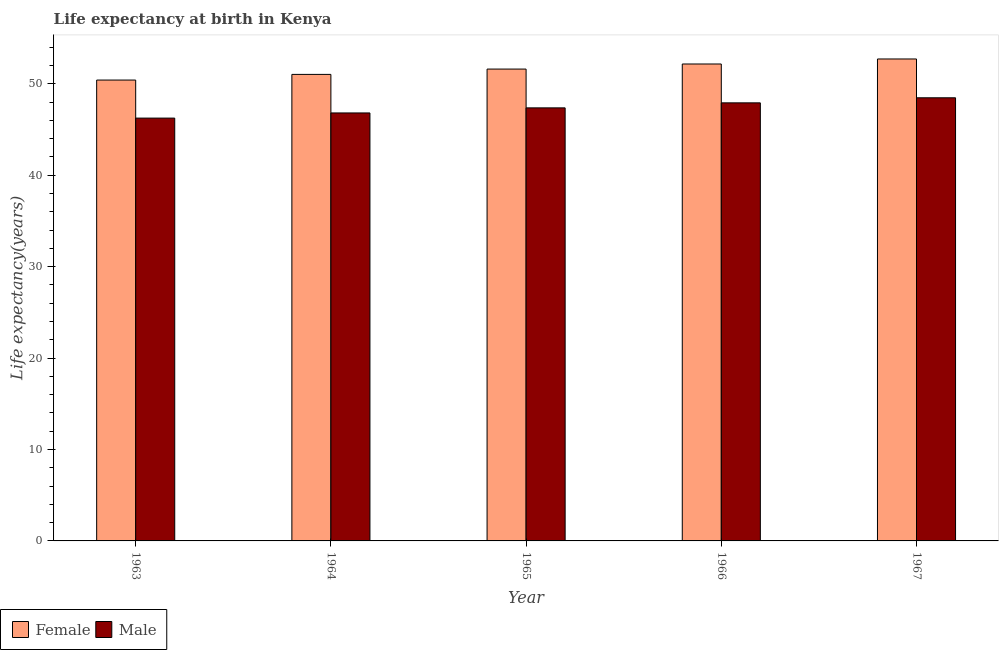How many different coloured bars are there?
Make the answer very short. 2. How many groups of bars are there?
Your response must be concise. 5. How many bars are there on the 4th tick from the left?
Ensure brevity in your answer.  2. What is the label of the 5th group of bars from the left?
Provide a succinct answer. 1967. What is the life expectancy(male) in 1963?
Your response must be concise. 46.24. Across all years, what is the maximum life expectancy(male)?
Offer a terse response. 48.46. Across all years, what is the minimum life expectancy(female)?
Make the answer very short. 50.4. In which year was the life expectancy(female) maximum?
Your response must be concise. 1967. What is the total life expectancy(female) in the graph?
Your response must be concise. 257.89. What is the difference between the life expectancy(male) in 1963 and that in 1966?
Make the answer very short. -1.67. What is the difference between the life expectancy(female) in 1963 and the life expectancy(male) in 1966?
Your answer should be compact. -1.76. What is the average life expectancy(female) per year?
Offer a terse response. 51.58. In how many years, is the life expectancy(male) greater than 22 years?
Provide a short and direct response. 5. What is the ratio of the life expectancy(female) in 1963 to that in 1967?
Ensure brevity in your answer.  0.96. Is the life expectancy(male) in 1963 less than that in 1964?
Make the answer very short. Yes. What is the difference between the highest and the second highest life expectancy(female)?
Keep it short and to the point. 0.55. What is the difference between the highest and the lowest life expectancy(male)?
Provide a succinct answer. 2.22. In how many years, is the life expectancy(female) greater than the average life expectancy(female) taken over all years?
Make the answer very short. 3. Is the sum of the life expectancy(female) in 1965 and 1967 greater than the maximum life expectancy(male) across all years?
Ensure brevity in your answer.  Yes. What does the 1st bar from the left in 1965 represents?
Provide a short and direct response. Female. How many years are there in the graph?
Your answer should be very brief. 5. Does the graph contain any zero values?
Keep it short and to the point. No. Does the graph contain grids?
Provide a succinct answer. No. How are the legend labels stacked?
Your answer should be compact. Horizontal. What is the title of the graph?
Your answer should be compact. Life expectancy at birth in Kenya. What is the label or title of the X-axis?
Ensure brevity in your answer.  Year. What is the label or title of the Y-axis?
Your answer should be very brief. Life expectancy(years). What is the Life expectancy(years) in Female in 1963?
Keep it short and to the point. 50.4. What is the Life expectancy(years) of Male in 1963?
Provide a succinct answer. 46.24. What is the Life expectancy(years) of Female in 1964?
Offer a very short reply. 51.02. What is the Life expectancy(years) of Male in 1964?
Ensure brevity in your answer.  46.8. What is the Life expectancy(years) in Female in 1965?
Keep it short and to the point. 51.6. What is the Life expectancy(years) of Male in 1965?
Ensure brevity in your answer.  47.36. What is the Life expectancy(years) in Female in 1966?
Offer a terse response. 52.16. What is the Life expectancy(years) of Male in 1966?
Make the answer very short. 47.91. What is the Life expectancy(years) of Female in 1967?
Your response must be concise. 52.71. What is the Life expectancy(years) of Male in 1967?
Your response must be concise. 48.46. Across all years, what is the maximum Life expectancy(years) of Female?
Your answer should be very brief. 52.71. Across all years, what is the maximum Life expectancy(years) of Male?
Keep it short and to the point. 48.46. Across all years, what is the minimum Life expectancy(years) of Female?
Keep it short and to the point. 50.4. Across all years, what is the minimum Life expectancy(years) of Male?
Ensure brevity in your answer.  46.24. What is the total Life expectancy(years) of Female in the graph?
Give a very brief answer. 257.89. What is the total Life expectancy(years) of Male in the graph?
Ensure brevity in your answer.  236.78. What is the difference between the Life expectancy(years) in Female in 1963 and that in 1964?
Provide a succinct answer. -0.62. What is the difference between the Life expectancy(years) in Male in 1963 and that in 1964?
Ensure brevity in your answer.  -0.56. What is the difference between the Life expectancy(years) of Female in 1963 and that in 1965?
Your answer should be very brief. -1.2. What is the difference between the Life expectancy(years) in Male in 1963 and that in 1965?
Your answer should be compact. -1.12. What is the difference between the Life expectancy(years) of Female in 1963 and that in 1966?
Make the answer very short. -1.76. What is the difference between the Life expectancy(years) of Male in 1963 and that in 1966?
Ensure brevity in your answer.  -1.67. What is the difference between the Life expectancy(years) in Female in 1963 and that in 1967?
Give a very brief answer. -2.31. What is the difference between the Life expectancy(years) in Male in 1963 and that in 1967?
Your answer should be compact. -2.22. What is the difference between the Life expectancy(years) of Female in 1964 and that in 1965?
Offer a terse response. -0.58. What is the difference between the Life expectancy(years) of Male in 1964 and that in 1965?
Keep it short and to the point. -0.55. What is the difference between the Life expectancy(years) in Female in 1964 and that in 1966?
Provide a succinct answer. -1.14. What is the difference between the Life expectancy(years) in Male in 1964 and that in 1966?
Ensure brevity in your answer.  -1.1. What is the difference between the Life expectancy(years) of Female in 1964 and that in 1967?
Your answer should be compact. -1.69. What is the difference between the Life expectancy(years) in Male in 1964 and that in 1967?
Offer a very short reply. -1.66. What is the difference between the Life expectancy(years) in Female in 1965 and that in 1966?
Ensure brevity in your answer.  -0.56. What is the difference between the Life expectancy(years) in Male in 1965 and that in 1966?
Provide a short and direct response. -0.55. What is the difference between the Life expectancy(years) of Female in 1965 and that in 1967?
Provide a succinct answer. -1.1. What is the difference between the Life expectancy(years) in Male in 1965 and that in 1967?
Your response must be concise. -1.1. What is the difference between the Life expectancy(years) of Female in 1966 and that in 1967?
Give a very brief answer. -0.55. What is the difference between the Life expectancy(years) in Male in 1966 and that in 1967?
Make the answer very short. -0.55. What is the difference between the Life expectancy(years) in Female in 1963 and the Life expectancy(years) in Male in 1964?
Offer a terse response. 3.6. What is the difference between the Life expectancy(years) of Female in 1963 and the Life expectancy(years) of Male in 1965?
Provide a short and direct response. 3.04. What is the difference between the Life expectancy(years) in Female in 1963 and the Life expectancy(years) in Male in 1966?
Your answer should be very brief. 2.49. What is the difference between the Life expectancy(years) of Female in 1963 and the Life expectancy(years) of Male in 1967?
Ensure brevity in your answer.  1.94. What is the difference between the Life expectancy(years) in Female in 1964 and the Life expectancy(years) in Male in 1965?
Your answer should be compact. 3.66. What is the difference between the Life expectancy(years) of Female in 1964 and the Life expectancy(years) of Male in 1966?
Your answer should be very brief. 3.11. What is the difference between the Life expectancy(years) of Female in 1964 and the Life expectancy(years) of Male in 1967?
Your response must be concise. 2.56. What is the difference between the Life expectancy(years) in Female in 1965 and the Life expectancy(years) in Male in 1966?
Offer a very short reply. 3.69. What is the difference between the Life expectancy(years) in Female in 1965 and the Life expectancy(years) in Male in 1967?
Your answer should be compact. 3.14. What is the difference between the Life expectancy(years) in Female in 1966 and the Life expectancy(years) in Male in 1967?
Provide a short and direct response. 3.7. What is the average Life expectancy(years) of Female per year?
Offer a very short reply. 51.58. What is the average Life expectancy(years) of Male per year?
Offer a terse response. 47.35. In the year 1963, what is the difference between the Life expectancy(years) of Female and Life expectancy(years) of Male?
Ensure brevity in your answer.  4.16. In the year 1964, what is the difference between the Life expectancy(years) of Female and Life expectancy(years) of Male?
Your answer should be compact. 4.21. In the year 1965, what is the difference between the Life expectancy(years) in Female and Life expectancy(years) in Male?
Your answer should be compact. 4.24. In the year 1966, what is the difference between the Life expectancy(years) of Female and Life expectancy(years) of Male?
Ensure brevity in your answer.  4.25. In the year 1967, what is the difference between the Life expectancy(years) in Female and Life expectancy(years) in Male?
Provide a short and direct response. 4.25. What is the ratio of the Life expectancy(years) in Female in 1963 to that in 1964?
Make the answer very short. 0.99. What is the ratio of the Life expectancy(years) of Male in 1963 to that in 1964?
Keep it short and to the point. 0.99. What is the ratio of the Life expectancy(years) in Female in 1963 to that in 1965?
Keep it short and to the point. 0.98. What is the ratio of the Life expectancy(years) of Male in 1963 to that in 1965?
Keep it short and to the point. 0.98. What is the ratio of the Life expectancy(years) of Female in 1963 to that in 1966?
Keep it short and to the point. 0.97. What is the ratio of the Life expectancy(years) of Male in 1963 to that in 1966?
Give a very brief answer. 0.97. What is the ratio of the Life expectancy(years) in Female in 1963 to that in 1967?
Give a very brief answer. 0.96. What is the ratio of the Life expectancy(years) in Male in 1963 to that in 1967?
Offer a terse response. 0.95. What is the ratio of the Life expectancy(years) of Female in 1964 to that in 1965?
Keep it short and to the point. 0.99. What is the ratio of the Life expectancy(years) of Male in 1964 to that in 1965?
Offer a very short reply. 0.99. What is the ratio of the Life expectancy(years) of Female in 1964 to that in 1966?
Ensure brevity in your answer.  0.98. What is the ratio of the Life expectancy(years) of Male in 1964 to that in 1967?
Offer a terse response. 0.97. What is the ratio of the Life expectancy(years) of Female in 1965 to that in 1966?
Offer a very short reply. 0.99. What is the ratio of the Life expectancy(years) of Female in 1965 to that in 1967?
Provide a short and direct response. 0.98. What is the ratio of the Life expectancy(years) of Male in 1965 to that in 1967?
Offer a terse response. 0.98. What is the ratio of the Life expectancy(years) in Female in 1966 to that in 1967?
Offer a terse response. 0.99. What is the ratio of the Life expectancy(years) in Male in 1966 to that in 1967?
Make the answer very short. 0.99. What is the difference between the highest and the second highest Life expectancy(years) of Female?
Offer a terse response. 0.55. What is the difference between the highest and the second highest Life expectancy(years) of Male?
Keep it short and to the point. 0.55. What is the difference between the highest and the lowest Life expectancy(years) of Female?
Provide a short and direct response. 2.31. What is the difference between the highest and the lowest Life expectancy(years) of Male?
Make the answer very short. 2.22. 